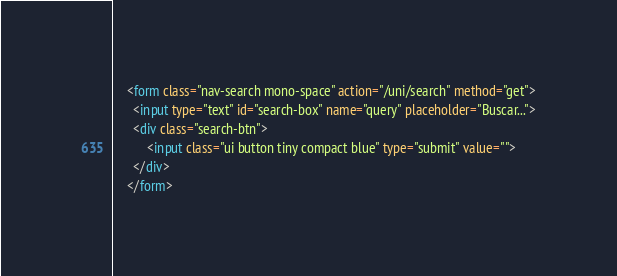Convert code to text. <code><loc_0><loc_0><loc_500><loc_500><_HTML_>    <form class="nav-search mono-space" action="/uni/search" method="get">
      <input type="text" id="search-box" name="query" placeholder="Buscar...">
      <div class="search-btn">
	      <input class="ui button tiny compact blue" type="submit" value="">
      </div>
    </form></code> 